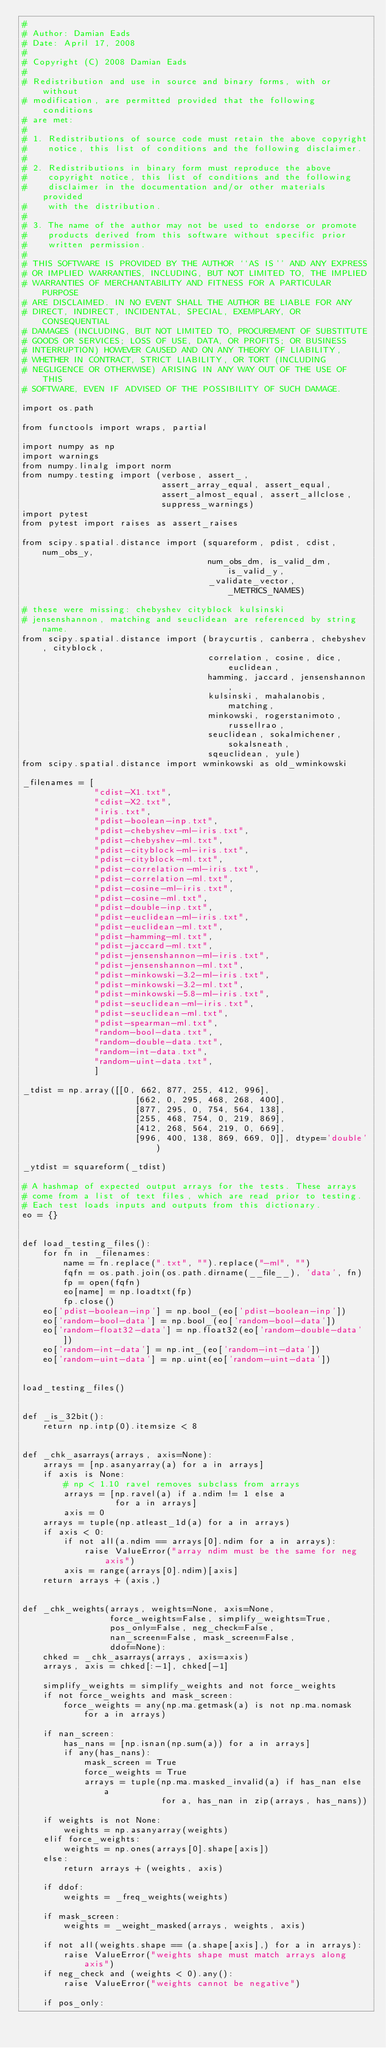Convert code to text. <code><loc_0><loc_0><loc_500><loc_500><_Python_>#
# Author: Damian Eads
# Date: April 17, 2008
#
# Copyright (C) 2008 Damian Eads
#
# Redistribution and use in source and binary forms, with or without
# modification, are permitted provided that the following conditions
# are met:
#
# 1. Redistributions of source code must retain the above copyright
#    notice, this list of conditions and the following disclaimer.
#
# 2. Redistributions in binary form must reproduce the above
#    copyright notice, this list of conditions and the following
#    disclaimer in the documentation and/or other materials provided
#    with the distribution.
#
# 3. The name of the author may not be used to endorse or promote
#    products derived from this software without specific prior
#    written permission.
#
# THIS SOFTWARE IS PROVIDED BY THE AUTHOR ``AS IS'' AND ANY EXPRESS
# OR IMPLIED WARRANTIES, INCLUDING, BUT NOT LIMITED TO, THE IMPLIED
# WARRANTIES OF MERCHANTABILITY AND FITNESS FOR A PARTICULAR PURPOSE
# ARE DISCLAIMED. IN NO EVENT SHALL THE AUTHOR BE LIABLE FOR ANY
# DIRECT, INDIRECT, INCIDENTAL, SPECIAL, EXEMPLARY, OR CONSEQUENTIAL
# DAMAGES (INCLUDING, BUT NOT LIMITED TO, PROCUREMENT OF SUBSTITUTE
# GOODS OR SERVICES; LOSS OF USE, DATA, OR PROFITS; OR BUSINESS
# INTERRUPTION) HOWEVER CAUSED AND ON ANY THEORY OF LIABILITY,
# WHETHER IN CONTRACT, STRICT LIABILITY, OR TORT (INCLUDING
# NEGLIGENCE OR OTHERWISE) ARISING IN ANY WAY OUT OF THE USE OF THIS
# SOFTWARE, EVEN IF ADVISED OF THE POSSIBILITY OF SUCH DAMAGE.

import os.path

from functools import wraps, partial

import numpy as np
import warnings
from numpy.linalg import norm
from numpy.testing import (verbose, assert_,
                           assert_array_equal, assert_equal,
                           assert_almost_equal, assert_allclose,
                           suppress_warnings)
import pytest
from pytest import raises as assert_raises

from scipy.spatial.distance import (squareform, pdist, cdist, num_obs_y,
                                    num_obs_dm, is_valid_dm, is_valid_y,
                                    _validate_vector, _METRICS_NAMES)

# these were missing: chebyshev cityblock kulsinski
# jensenshannon, matching and seuclidean are referenced by string name.
from scipy.spatial.distance import (braycurtis, canberra, chebyshev, cityblock,
                                    correlation, cosine, dice, euclidean,
                                    hamming, jaccard, jensenshannon,
                                    kulsinski, mahalanobis, matching,
                                    minkowski, rogerstanimoto, russellrao,
                                    seuclidean, sokalmichener, sokalsneath,
                                    sqeuclidean, yule)
from scipy.spatial.distance import wminkowski as old_wminkowski

_filenames = [
              "cdist-X1.txt",
              "cdist-X2.txt",
              "iris.txt",
              "pdist-boolean-inp.txt",
              "pdist-chebyshev-ml-iris.txt",
              "pdist-chebyshev-ml.txt",
              "pdist-cityblock-ml-iris.txt",
              "pdist-cityblock-ml.txt",
              "pdist-correlation-ml-iris.txt",
              "pdist-correlation-ml.txt",
              "pdist-cosine-ml-iris.txt",
              "pdist-cosine-ml.txt",
              "pdist-double-inp.txt",
              "pdist-euclidean-ml-iris.txt",
              "pdist-euclidean-ml.txt",
              "pdist-hamming-ml.txt",
              "pdist-jaccard-ml.txt",
              "pdist-jensenshannon-ml-iris.txt",
              "pdist-jensenshannon-ml.txt",
              "pdist-minkowski-3.2-ml-iris.txt",
              "pdist-minkowski-3.2-ml.txt",
              "pdist-minkowski-5.8-ml-iris.txt",
              "pdist-seuclidean-ml-iris.txt",
              "pdist-seuclidean-ml.txt",
              "pdist-spearman-ml.txt",
              "random-bool-data.txt",
              "random-double-data.txt",
              "random-int-data.txt",
              "random-uint-data.txt",
              ]

_tdist = np.array([[0, 662, 877, 255, 412, 996],
                      [662, 0, 295, 468, 268, 400],
                      [877, 295, 0, 754, 564, 138],
                      [255, 468, 754, 0, 219, 869],
                      [412, 268, 564, 219, 0, 669],
                      [996, 400, 138, 869, 669, 0]], dtype='double')

_ytdist = squareform(_tdist)

# A hashmap of expected output arrays for the tests. These arrays
# come from a list of text files, which are read prior to testing.
# Each test loads inputs and outputs from this dictionary.
eo = {}


def load_testing_files():
    for fn in _filenames:
        name = fn.replace(".txt", "").replace("-ml", "")
        fqfn = os.path.join(os.path.dirname(__file__), 'data', fn)
        fp = open(fqfn)
        eo[name] = np.loadtxt(fp)
        fp.close()
    eo['pdist-boolean-inp'] = np.bool_(eo['pdist-boolean-inp'])
    eo['random-bool-data'] = np.bool_(eo['random-bool-data'])
    eo['random-float32-data'] = np.float32(eo['random-double-data'])
    eo['random-int-data'] = np.int_(eo['random-int-data'])
    eo['random-uint-data'] = np.uint(eo['random-uint-data'])


load_testing_files()


def _is_32bit():
    return np.intp(0).itemsize < 8


def _chk_asarrays(arrays, axis=None):
    arrays = [np.asanyarray(a) for a in arrays]
    if axis is None:
        # np < 1.10 ravel removes subclass from arrays
        arrays = [np.ravel(a) if a.ndim != 1 else a
                  for a in arrays]
        axis = 0
    arrays = tuple(np.atleast_1d(a) for a in arrays)
    if axis < 0:
        if not all(a.ndim == arrays[0].ndim for a in arrays):
            raise ValueError("array ndim must be the same for neg axis")
        axis = range(arrays[0].ndim)[axis]
    return arrays + (axis,)


def _chk_weights(arrays, weights=None, axis=None,
                 force_weights=False, simplify_weights=True,
                 pos_only=False, neg_check=False,
                 nan_screen=False, mask_screen=False,
                 ddof=None):
    chked = _chk_asarrays(arrays, axis=axis)
    arrays, axis = chked[:-1], chked[-1]

    simplify_weights = simplify_weights and not force_weights
    if not force_weights and mask_screen:
        force_weights = any(np.ma.getmask(a) is not np.ma.nomask for a in arrays)

    if nan_screen:
        has_nans = [np.isnan(np.sum(a)) for a in arrays]
        if any(has_nans):
            mask_screen = True
            force_weights = True
            arrays = tuple(np.ma.masked_invalid(a) if has_nan else a
                           for a, has_nan in zip(arrays, has_nans))

    if weights is not None:
        weights = np.asanyarray(weights)
    elif force_weights:
        weights = np.ones(arrays[0].shape[axis])
    else:
        return arrays + (weights, axis)

    if ddof:
        weights = _freq_weights(weights)

    if mask_screen:
        weights = _weight_masked(arrays, weights, axis)

    if not all(weights.shape == (a.shape[axis],) for a in arrays):
        raise ValueError("weights shape must match arrays along axis")
    if neg_check and (weights < 0).any():
        raise ValueError("weights cannot be negative")

    if pos_only:</code> 